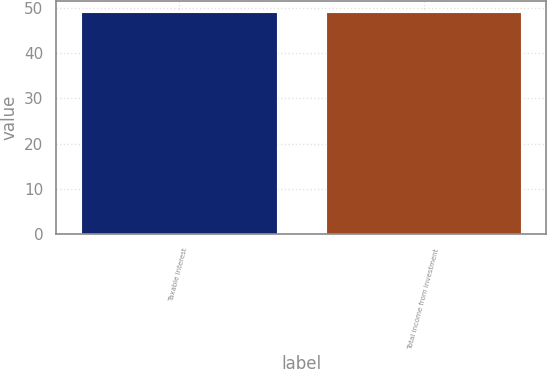Convert chart to OTSL. <chart><loc_0><loc_0><loc_500><loc_500><bar_chart><fcel>Taxable interest<fcel>Total income from investment<nl><fcel>49<fcel>49.1<nl></chart> 